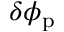<formula> <loc_0><loc_0><loc_500><loc_500>\delta \phi _ { p }</formula> 